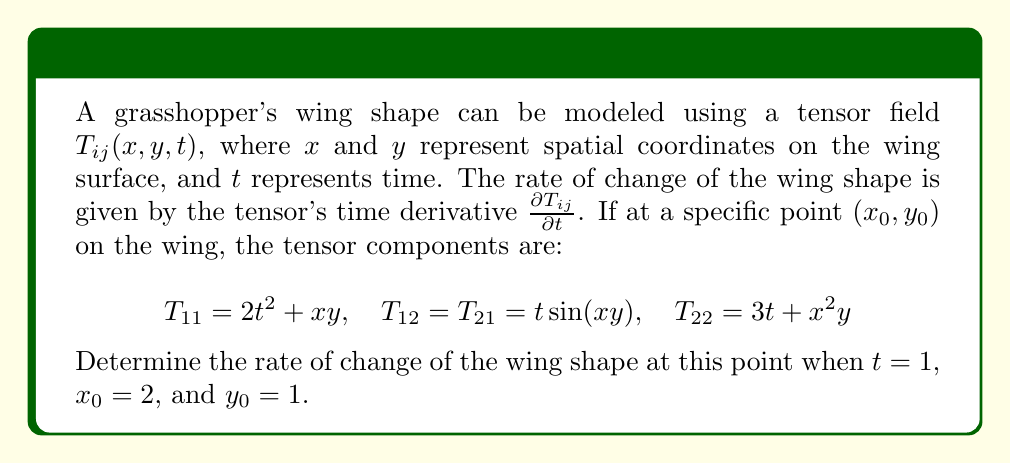Solve this math problem. To solve this problem, we need to follow these steps:

1) The rate of change of the wing shape is given by the time derivative of the tensor field $\frac{\partial T_{ij}}{\partial t}$.

2) We need to calculate this derivative for each component of the tensor:

   For $T_{11}$: 
   $$\frac{\partial T_{11}}{\partial t} = \frac{\partial}{\partial t}(2t^2 + xy) = 4t$$

   For $T_{12}$ and $T_{21}$: 
   $$\frac{\partial T_{12}}{\partial t} = \frac{\partial T_{21}}{\partial t} = \frac{\partial}{\partial t}(t\sin(xy)) = \sin(xy)$$

   For $T_{22}$: 
   $$\frac{\partial T_{22}}{\partial t} = \frac{\partial}{\partial t}(3t + x^2y) = 3$$

3) Now we need to evaluate these derivatives at the given point and time:
   $t = 1$, $x_0 = 2$, and $y_0 = 1$

   For $\frac{\partial T_{11}}{\partial t}$: 
   $$\frac{\partial T_{11}}{\partial t} = 4t = 4(1) = 4$$

   For $\frac{\partial T_{12}}{\partial t}$ and $\frac{\partial T_{21}}{\partial t}$: 
   $$\frac{\partial T_{12}}{\partial t} = \frac{\partial T_{21}}{\partial t} = \sin(xy) = \sin(2 \cdot 1) = \sin(2)$$

   For $\frac{\partial T_{22}}{\partial t}$: 
   $$\frac{\partial T_{22}}{\partial t} = 3$$

4) The rate of change of the wing shape at this point is represented by the tensor:

   $$\frac{\partial T_{ij}}{\partial t} = \begin{pmatrix} 
   4 & \sin(2) \\
   \sin(2) & 3
   \end{pmatrix}$$

This tensor describes how quickly the wing shape is changing in different directions at the specified point on the wing.
Answer: $$\frac{\partial T_{ij}}{\partial t} = \begin{pmatrix} 
4 & \sin(2) \\
\sin(2) & 3
\end{pmatrix}$$ 